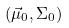Convert formula to latex. <formula><loc_0><loc_0><loc_500><loc_500>( \vec { \mu } _ { 0 } , \Sigma _ { 0 } )</formula> 